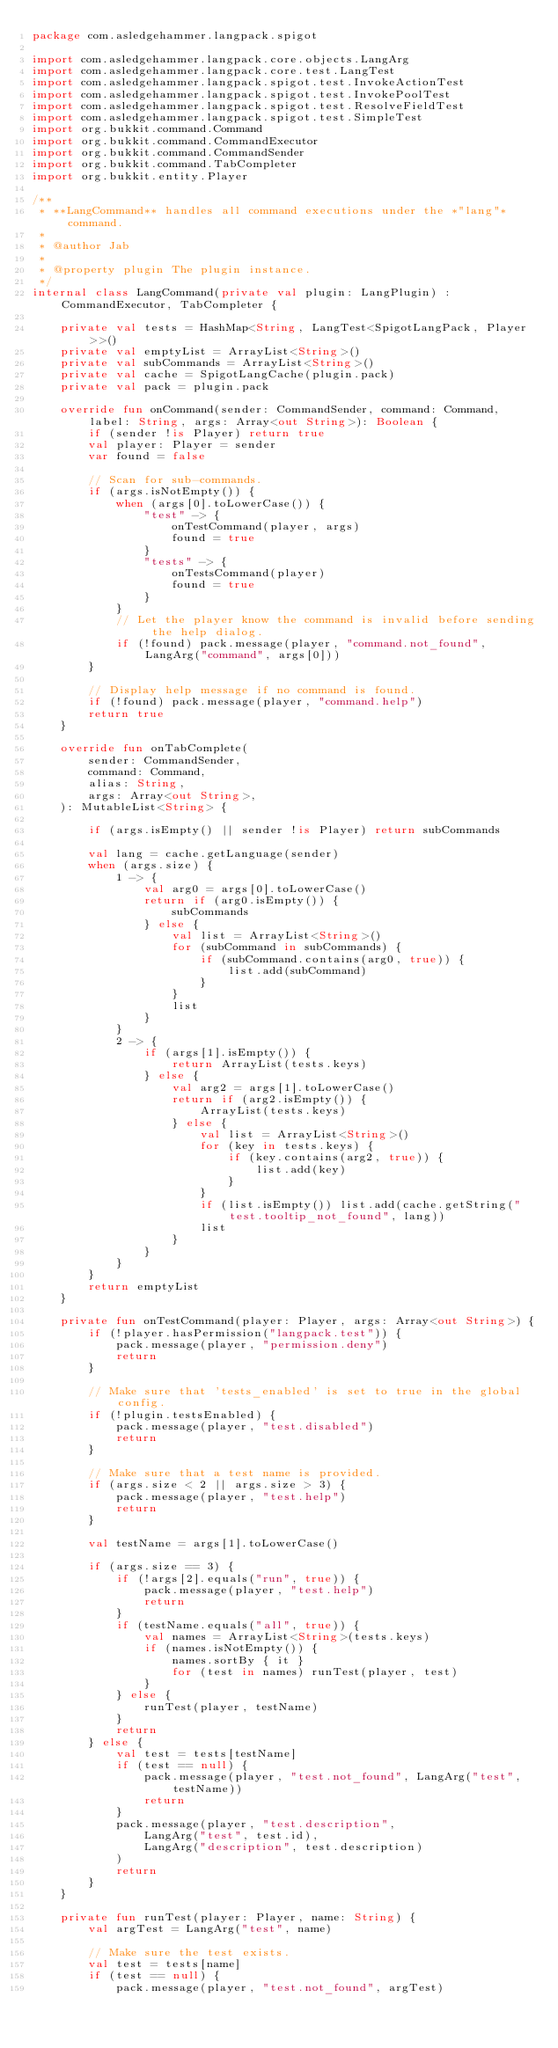Convert code to text. <code><loc_0><loc_0><loc_500><loc_500><_Kotlin_>package com.asledgehammer.langpack.spigot

import com.asledgehammer.langpack.core.objects.LangArg
import com.asledgehammer.langpack.core.test.LangTest
import com.asledgehammer.langpack.spigot.test.InvokeActionTest
import com.asledgehammer.langpack.spigot.test.InvokePoolTest
import com.asledgehammer.langpack.spigot.test.ResolveFieldTest
import com.asledgehammer.langpack.spigot.test.SimpleTest
import org.bukkit.command.Command
import org.bukkit.command.CommandExecutor
import org.bukkit.command.CommandSender
import org.bukkit.command.TabCompleter
import org.bukkit.entity.Player

/**
 * **LangCommand** handles all command executions under the *"lang"* command.
 *
 * @author Jab
 *
 * @property plugin The plugin instance.
 */
internal class LangCommand(private val plugin: LangPlugin) : CommandExecutor, TabCompleter {

    private val tests = HashMap<String, LangTest<SpigotLangPack, Player>>()
    private val emptyList = ArrayList<String>()
    private val subCommands = ArrayList<String>()
    private val cache = SpigotLangCache(plugin.pack)
    private val pack = plugin.pack

    override fun onCommand(sender: CommandSender, command: Command, label: String, args: Array<out String>): Boolean {
        if (sender !is Player) return true
        val player: Player = sender
        var found = false

        // Scan for sub-commands.
        if (args.isNotEmpty()) {
            when (args[0].toLowerCase()) {
                "test" -> {
                    onTestCommand(player, args)
                    found = true
                }
                "tests" -> {
                    onTestsCommand(player)
                    found = true
                }
            }
            // Let the player know the command is invalid before sending the help dialog.
            if (!found) pack.message(player, "command.not_found", LangArg("command", args[0]))
        }

        // Display help message if no command is found.
        if (!found) pack.message(player, "command.help")
        return true
    }

    override fun onTabComplete(
        sender: CommandSender,
        command: Command,
        alias: String,
        args: Array<out String>,
    ): MutableList<String> {

        if (args.isEmpty() || sender !is Player) return subCommands

        val lang = cache.getLanguage(sender)
        when (args.size) {
            1 -> {
                val arg0 = args[0].toLowerCase()
                return if (arg0.isEmpty()) {
                    subCommands
                } else {
                    val list = ArrayList<String>()
                    for (subCommand in subCommands) {
                        if (subCommand.contains(arg0, true)) {
                            list.add(subCommand)
                        }
                    }
                    list
                }
            }
            2 -> {
                if (args[1].isEmpty()) {
                    return ArrayList(tests.keys)
                } else {
                    val arg2 = args[1].toLowerCase()
                    return if (arg2.isEmpty()) {
                        ArrayList(tests.keys)
                    } else {
                        val list = ArrayList<String>()
                        for (key in tests.keys) {
                            if (key.contains(arg2, true)) {
                                list.add(key)
                            }
                        }
                        if (list.isEmpty()) list.add(cache.getString("test.tooltip_not_found", lang))
                        list
                    }
                }
            }
        }
        return emptyList
    }

    private fun onTestCommand(player: Player, args: Array<out String>) {
        if (!player.hasPermission("langpack.test")) {
            pack.message(player, "permission.deny")
            return
        }

        // Make sure that 'tests_enabled' is set to true in the global config.
        if (!plugin.testsEnabled) {
            pack.message(player, "test.disabled")
            return
        }

        // Make sure that a test name is provided.
        if (args.size < 2 || args.size > 3) {
            pack.message(player, "test.help")
            return
        }

        val testName = args[1].toLowerCase()

        if (args.size == 3) {
            if (!args[2].equals("run", true)) {
                pack.message(player, "test.help")
                return
            }
            if (testName.equals("all", true)) {
                val names = ArrayList<String>(tests.keys)
                if (names.isNotEmpty()) {
                    names.sortBy { it }
                    for (test in names) runTest(player, test)
                }
            } else {
                runTest(player, testName)
            }
            return
        } else {
            val test = tests[testName]
            if (test == null) {
                pack.message(player, "test.not_found", LangArg("test", testName))
                return
            }
            pack.message(player, "test.description",
                LangArg("test", test.id),
                LangArg("description", test.description)
            )
            return
        }
    }

    private fun runTest(player: Player, name: String) {
        val argTest = LangArg("test", name)

        // Make sure the test exists.
        val test = tests[name]
        if (test == null) {
            pack.message(player, "test.not_found", argTest)</code> 